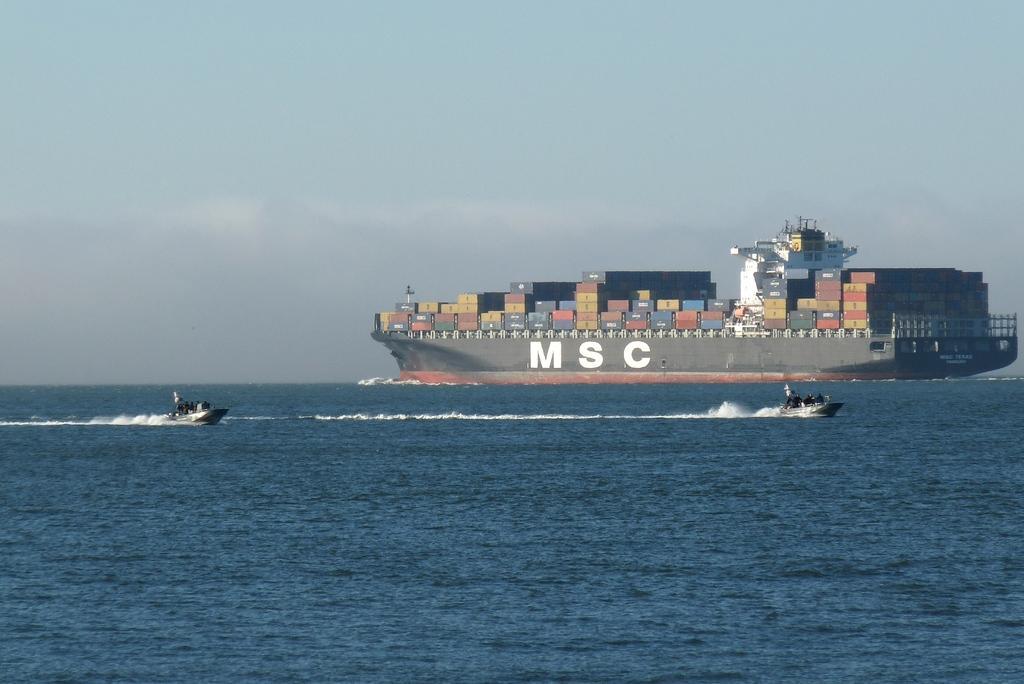Please provide a concise description of this image. In the picture we can see a ship on the water and goods on the ship and on the ship we can see a name MSC and just beside it, we can see two other boats on the water and the water is blue in color and in the background we can see a sky. 